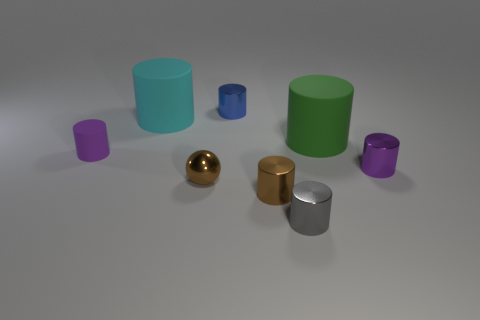Subtract all blue cylinders. How many cylinders are left? 6 Subtract all big cyan cylinders. How many cylinders are left? 6 Subtract all brown cylinders. Subtract all green blocks. How many cylinders are left? 6 Add 2 purple matte cylinders. How many objects exist? 10 Subtract all cylinders. How many objects are left? 1 Subtract 0 brown cubes. How many objects are left? 8 Subtract all small balls. Subtract all purple shiny cylinders. How many objects are left? 6 Add 2 tiny objects. How many tiny objects are left? 8 Add 2 large brown cylinders. How many large brown cylinders exist? 2 